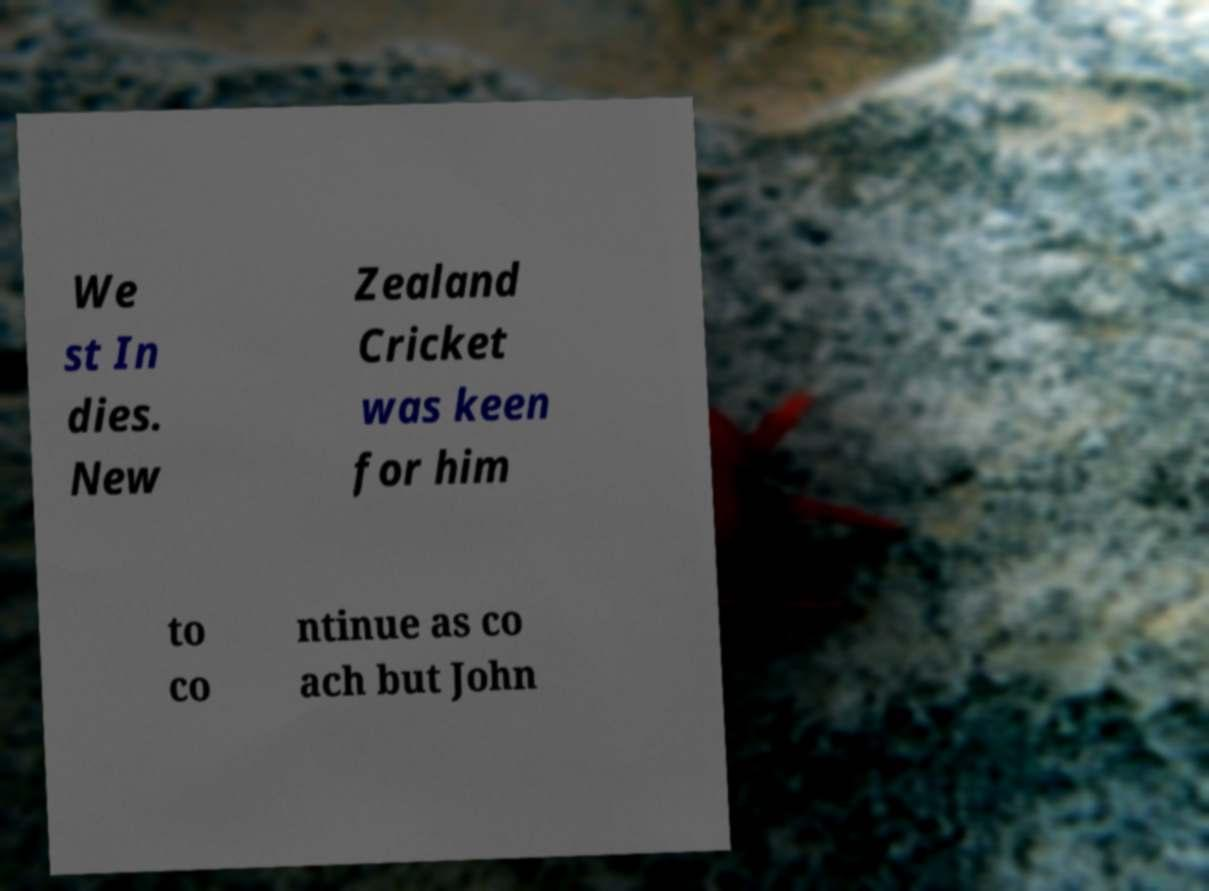Please identify and transcribe the text found in this image. We st In dies. New Zealand Cricket was keen for him to co ntinue as co ach but John 